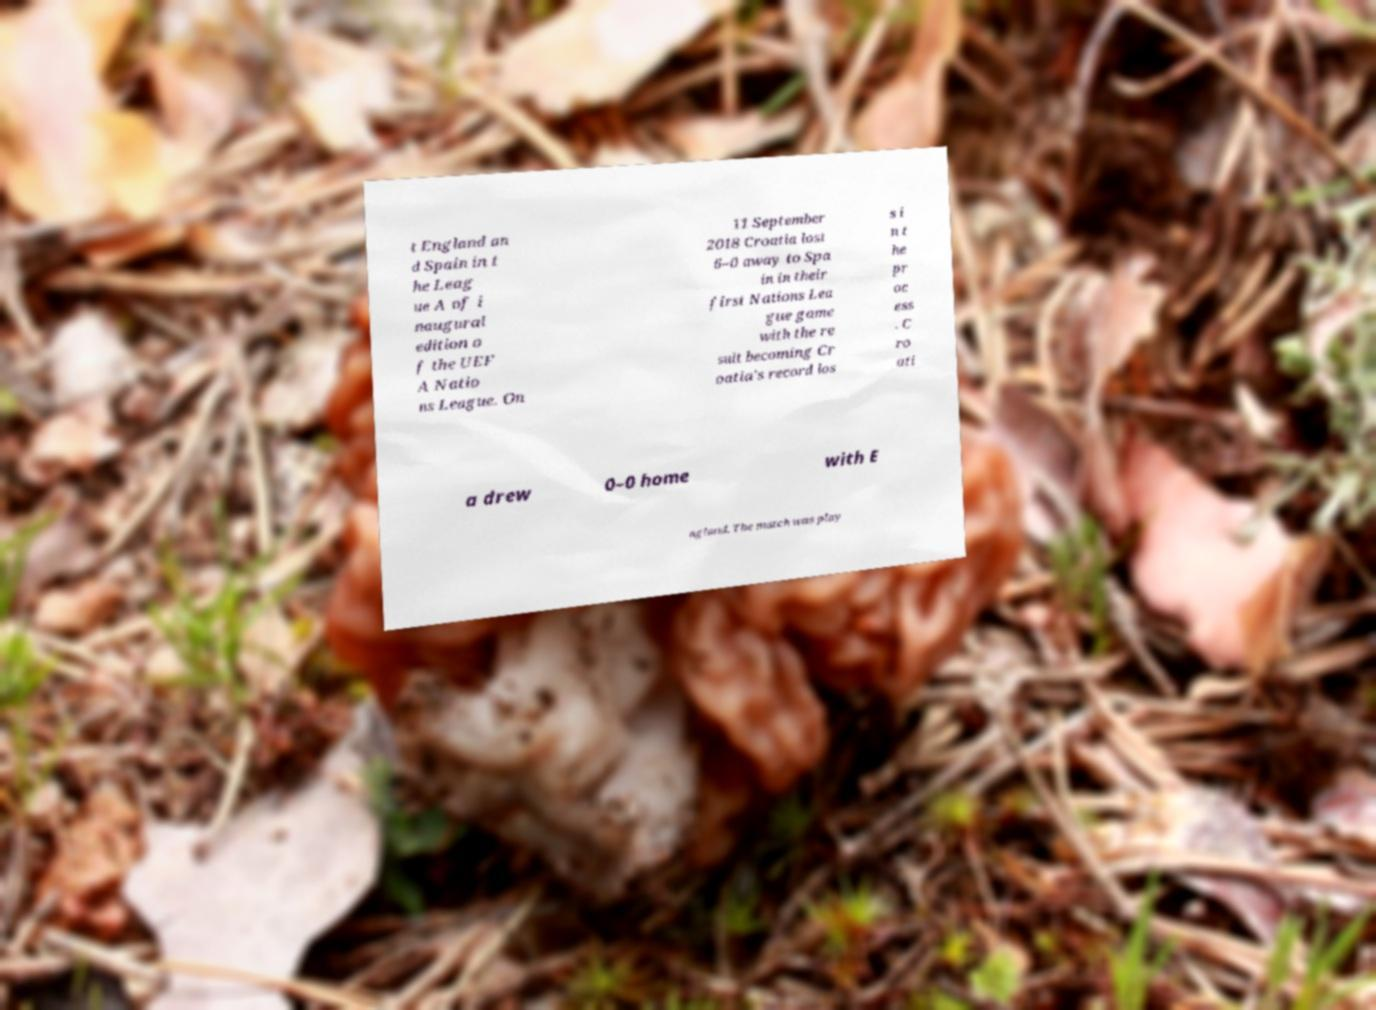Can you read and provide the text displayed in the image?This photo seems to have some interesting text. Can you extract and type it out for me? t England an d Spain in t he Leag ue A of i naugural edition o f the UEF A Natio ns League. On 11 September 2018 Croatia lost 6–0 away to Spa in in their first Nations Lea gue game with the re sult becoming Cr oatia's record los s i n t he pr oc ess . C ro ati a drew 0–0 home with E ngland. The match was play 